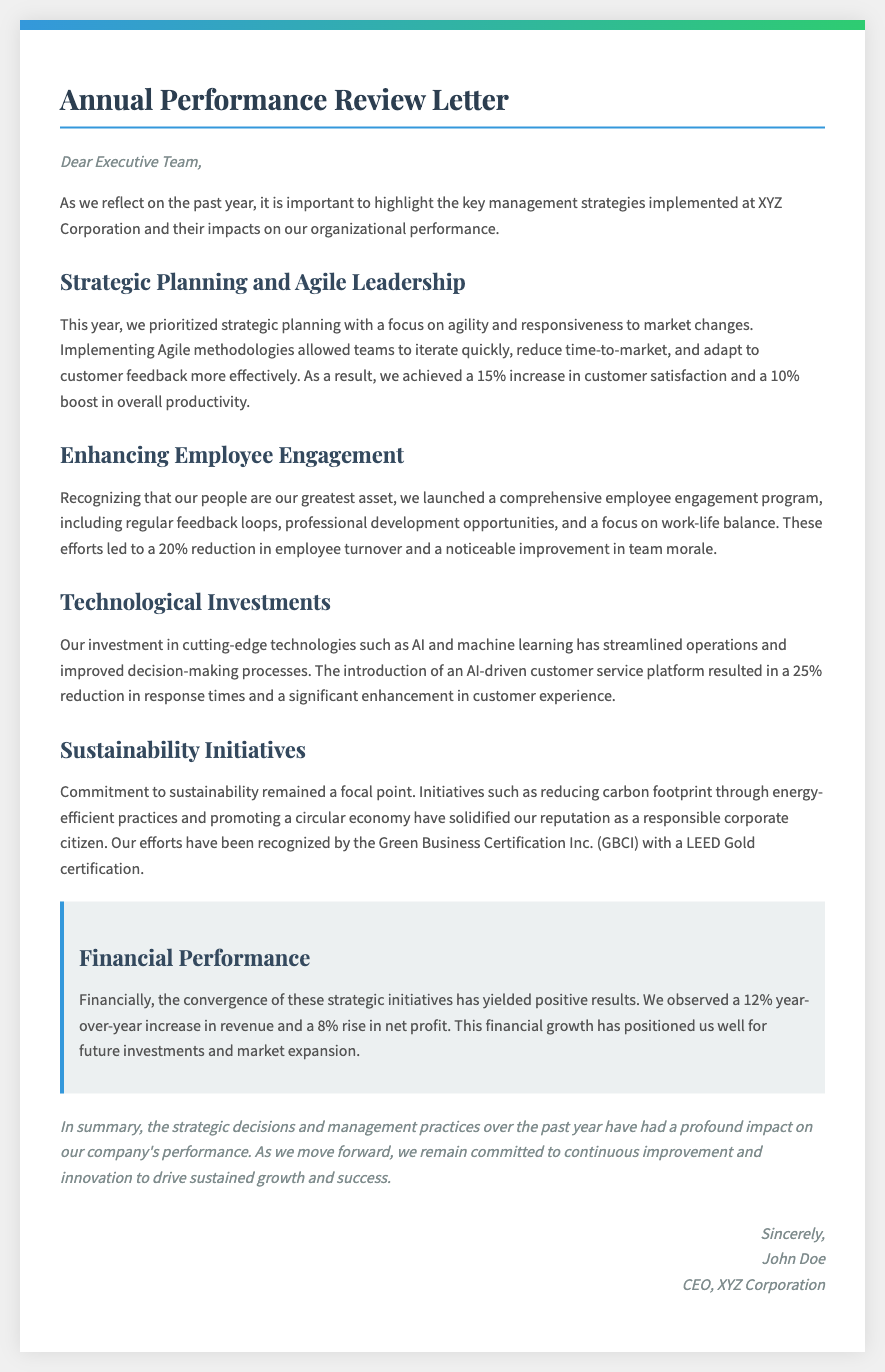what is the year-over-year increase in revenue? The letter states that there was a 12% year-over-year increase in revenue.
Answer: 12% what percentage increase was achieved in customer satisfaction? It is mentioned that there was a 15% increase in customer satisfaction due to the strategies implemented.
Answer: 15% what technology was introduced to improve customer service? The document highlights the introduction of an AI-driven customer service platform.
Answer: AI-driven customer service platform what was the impact on employee turnover? The engagement program led to a 20% reduction in employee turnover.
Answer: 20% who is the author of the letter? The closing section lists the signature of the letter, identifying the author as John Doe.
Answer: John Doe what certification did the company receive for its sustainability initiatives? The letter mentions that the company received LEED Gold certification from GBCI.
Answer: LEED Gold certification how much was the increase in net profit? It states there was an 8% rise in net profit mentioned in the financial performance section.
Answer: 8% which management approach did the company implement to improve productivity? The document refers to the implementation of Agile methodologies to improve productivity.
Answer: Agile methodologies what is the main focus of the employee engagement program? The program focuses on regular feedback loops, professional development opportunities, and a focus on work-life balance.
Answer: employee engagement program 